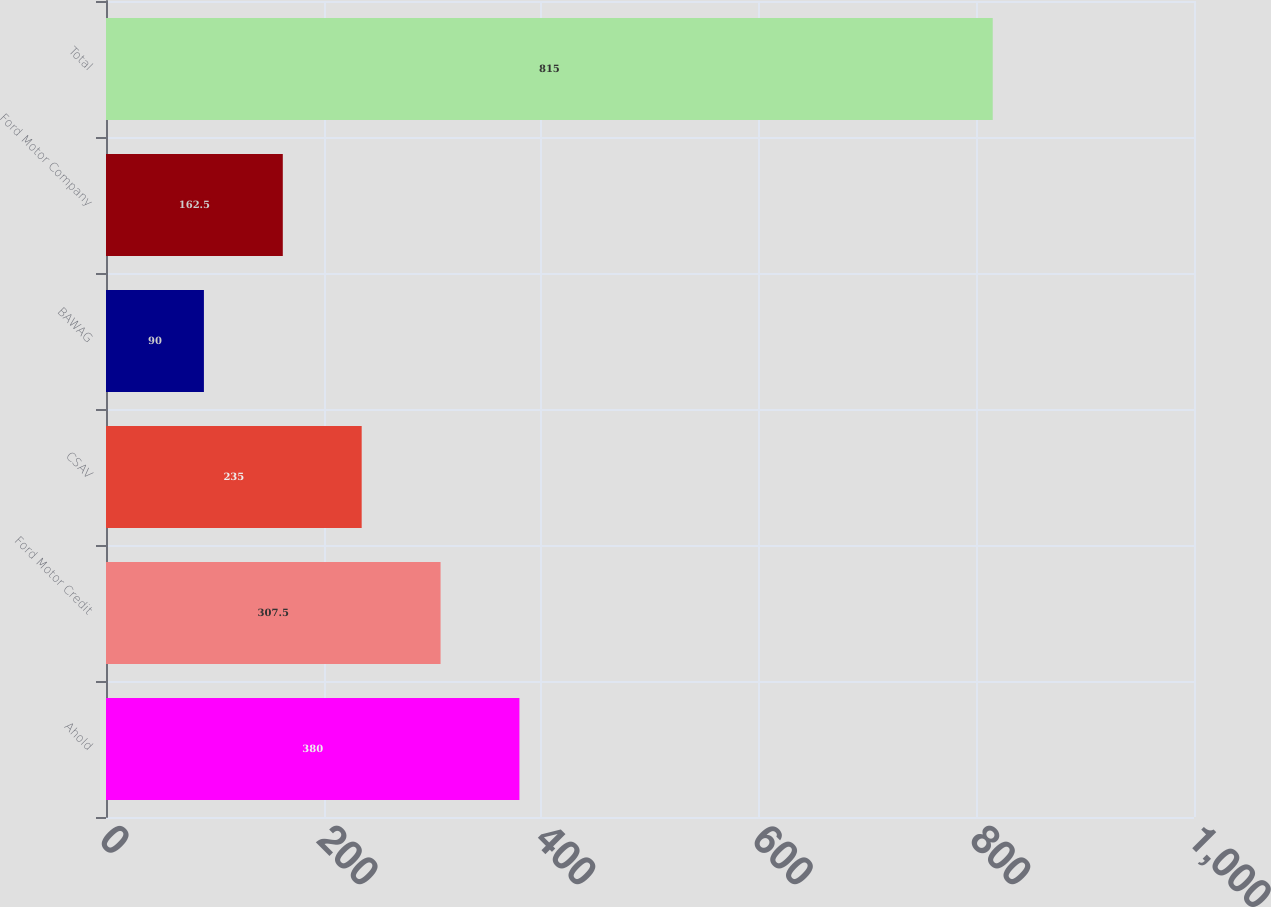<chart> <loc_0><loc_0><loc_500><loc_500><bar_chart><fcel>Ahold<fcel>Ford Motor Credit<fcel>CSAV<fcel>BAWAG<fcel>Ford Motor Company<fcel>Total<nl><fcel>380<fcel>307.5<fcel>235<fcel>90<fcel>162.5<fcel>815<nl></chart> 